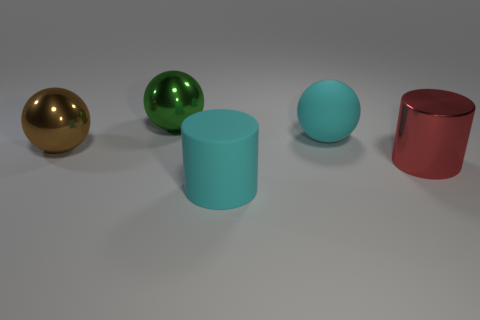Add 5 shiny spheres. How many objects exist? 10 Subtract all red cylinders. How many cylinders are left? 1 Subtract 0 yellow cylinders. How many objects are left? 5 Subtract all cylinders. How many objects are left? 3 Subtract 2 cylinders. How many cylinders are left? 0 Subtract all gray cylinders. Subtract all blue balls. How many cylinders are left? 2 Subtract all green cylinders. How many green spheres are left? 1 Subtract all big metallic cylinders. Subtract all big cyan rubber objects. How many objects are left? 2 Add 4 brown shiny balls. How many brown shiny balls are left? 5 Add 4 big purple cubes. How many big purple cubes exist? 4 